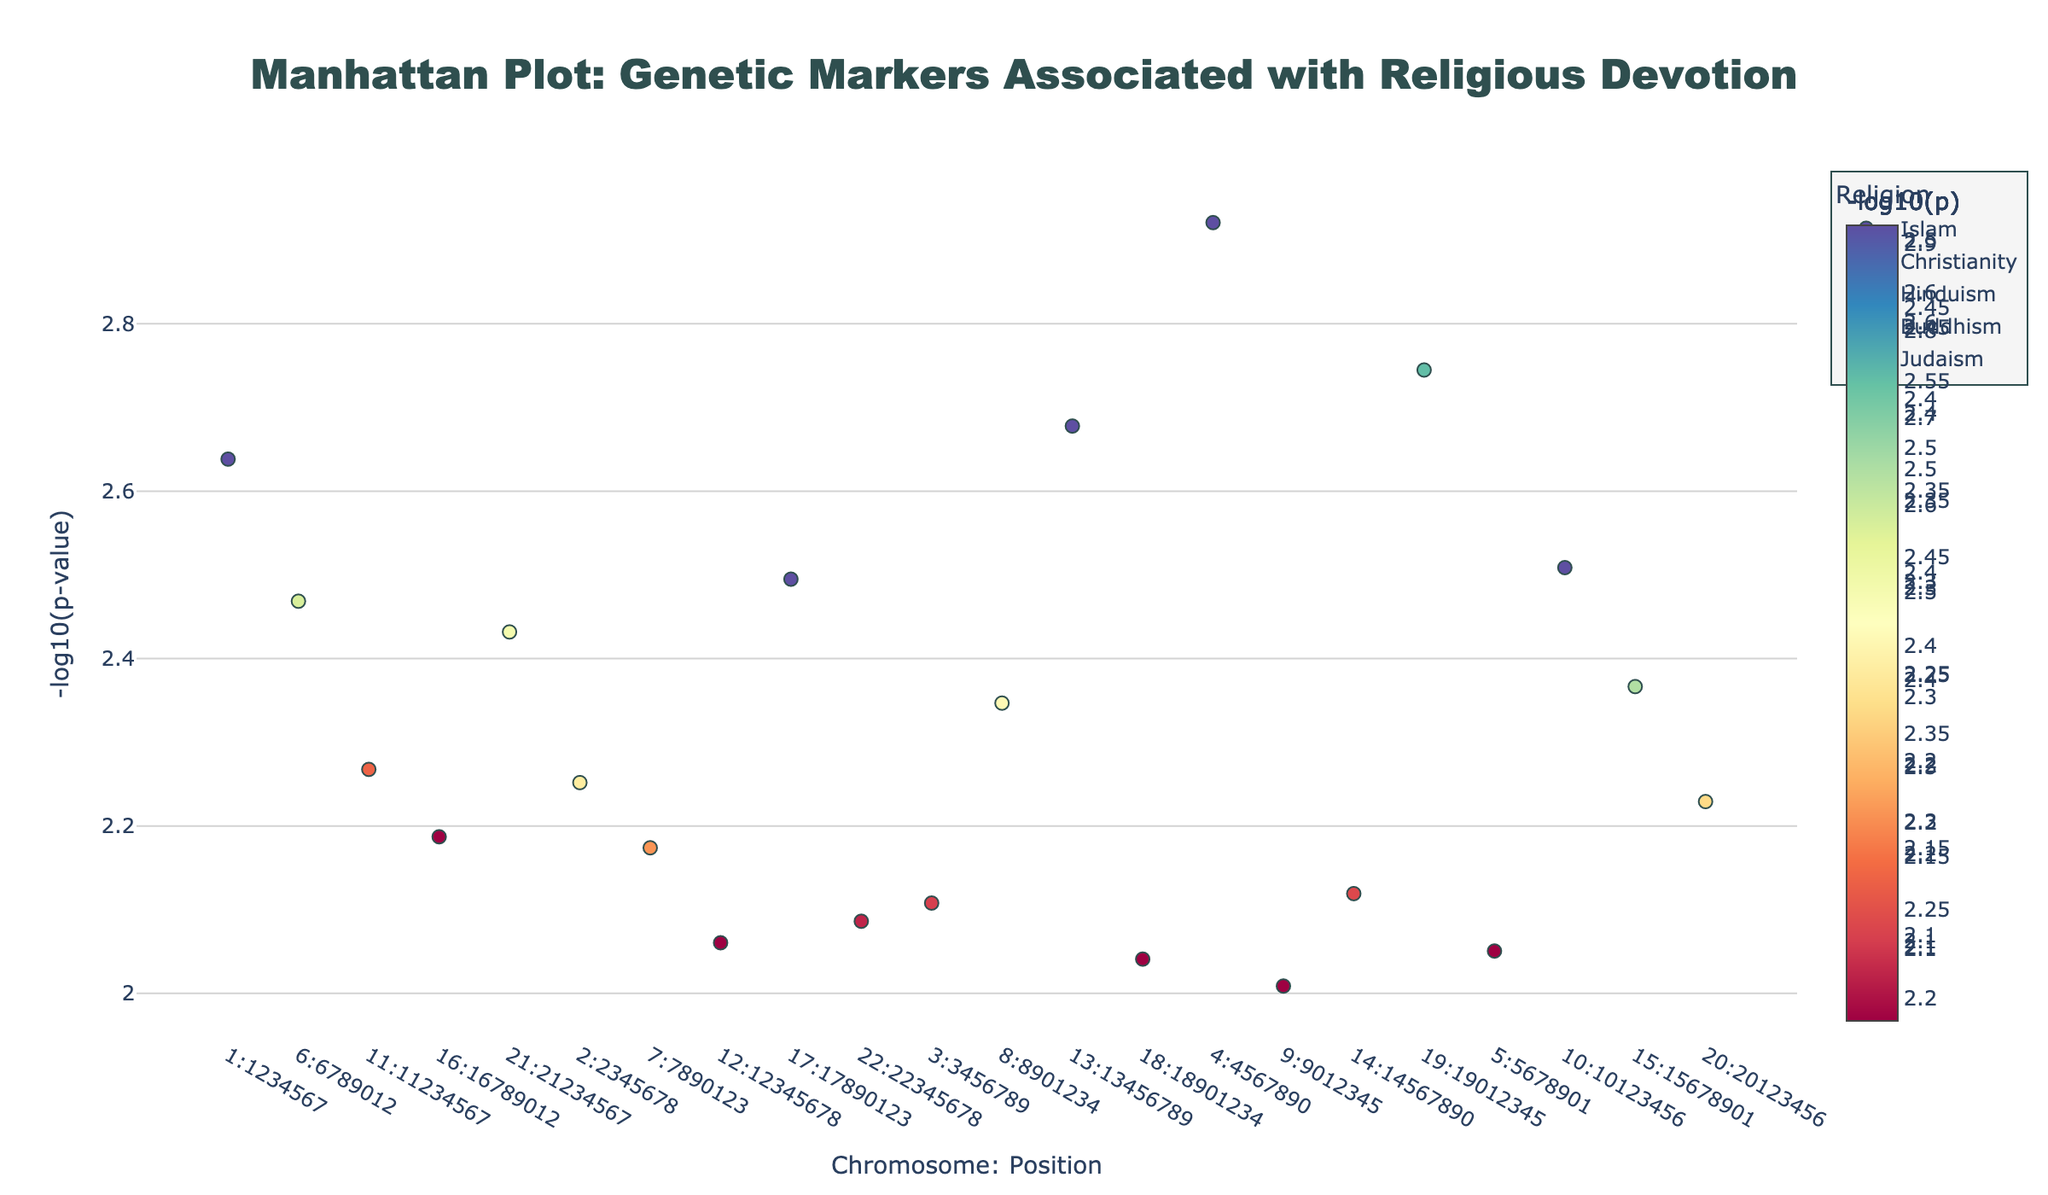Which religion has the genetic marker with the lowest P-value? The marker with the lowest P-value indicates the most significant result. In the plot, Buddhism has the marker rs1042778 at position 4567890 on chromosome 4 with the lowest P-value of 0.0012.
Answer: Buddhism How many genetic markers are associated with Islam? To determine this, count the markers colored for Islam in the plot. These markers are rs1800955, rs2254298, rs53576, rs2268498, and rs53576 again, totaling 5 markers.
Answer: 5 What is the highest -log10(P-value) for markers associated with Christianity? The highest -log10(P-value) indicates the most significant result. For Christianity, the markers are rs2268498, rs1006737, rs2254298, rs3796863, and rs1042778, with the highest -log10(P-value) corresponding to the lowest P-value, which is from rs2268498 on chromosome 2 with a P-value of 0.0056 (-log10(0.0056) ≈ 2.252).
Answer: 2.252 Which chromosomes have markers with P-values less than 0.002? To find this, identify the markers where P-values are less than 0.002. These markers are rs1042778 on chromosome 4 (P-value 0.0012) and rs4680 on chromosome 19 (P-value 0.0018). So, the chromosomes are 4 and 19.
Answer: 4 and 19 What is the sum of the -log10(P-values) for all markers associated with Judaism? To find this, calculate the -log10(P-values) for each Judaism-associated marker and sum them. Markers are rs3796863 (2.051), rs237887 (2.509), rr1800955 (2.367), and rs2268491 (2.229). The sum is 2.051 + 2.509 + 2.367 + 2.229 ≈ 9.156.
Answer: 9.156 Which genetic marker has the largest difference in -log10(P-value) between its appearance in two different religions? By checking each marker that appears in multiple religions and comparing their -log10(P-values): rs1800955 (Islam ≈ 2.638, Judaism ≈ 2.367), rs2268498 (Christianity ≈ 2.252, Islam ≈ 2.187). The largest difference is for rs1800955 (2.638 - 2.367 ≈ 0.271).
Answer: rs1800955 What is the average -log10(P-value) for markers on chromosome 7? There is one marker on chromosome 7 (rs1006737 for Christianity) with a P-value of 0.0067 giving -log10(0.0067) ≈ 2.174. As there is only one data point: 2.174 / 1 = 2.174.
Answer: 2.174 Which genetic marker is associated with both Hinduism and Buddhism, and what is its -log10(P-value) for each? The marker that appears in both Hinduism and Buddhism is rs1042778. For Hinduism (P-value 0.0021, -log10(P) ≈ 2.678) and Buddhism (P-value 0.0012, -log10(P) ≈ 2.921).
Answer: rs1042778, 2.678 for Hinduism and 2.921 for Buddhism 